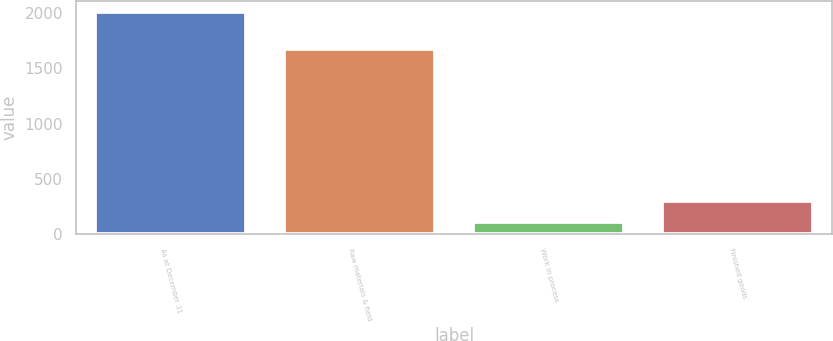Convert chart to OTSL. <chart><loc_0><loc_0><loc_500><loc_500><bar_chart><fcel>As at December 31<fcel>Raw materials & field<fcel>Work in process<fcel>Finished goods<nl><fcel>2008<fcel>1674<fcel>113<fcel>302.5<nl></chart> 